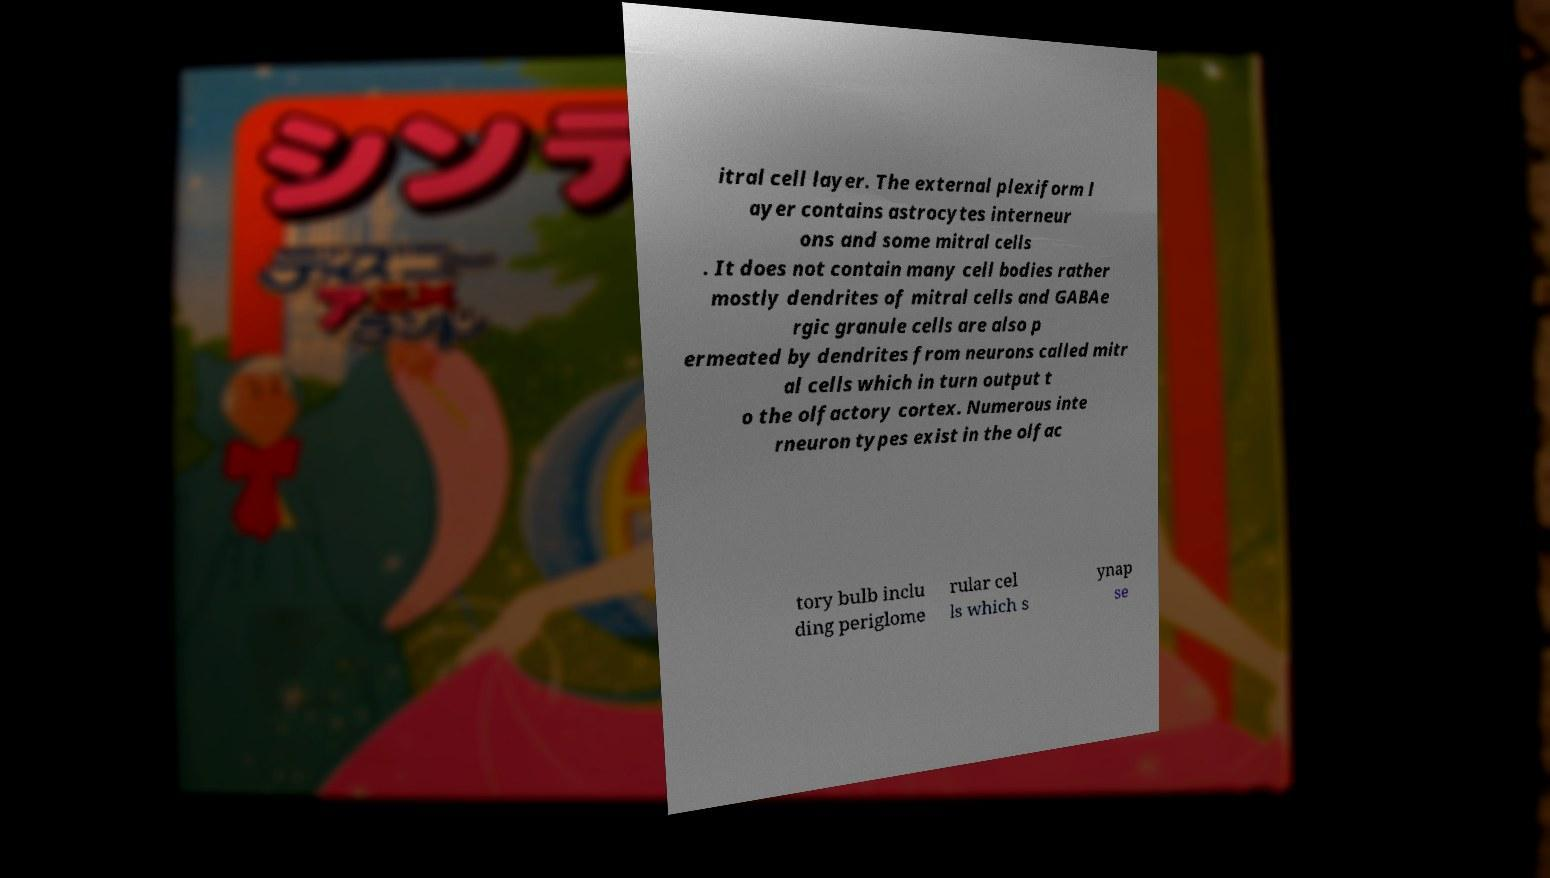Please read and relay the text visible in this image. What does it say? itral cell layer. The external plexiform l ayer contains astrocytes interneur ons and some mitral cells . It does not contain many cell bodies rather mostly dendrites of mitral cells and GABAe rgic granule cells are also p ermeated by dendrites from neurons called mitr al cells which in turn output t o the olfactory cortex. Numerous inte rneuron types exist in the olfac tory bulb inclu ding periglome rular cel ls which s ynap se 